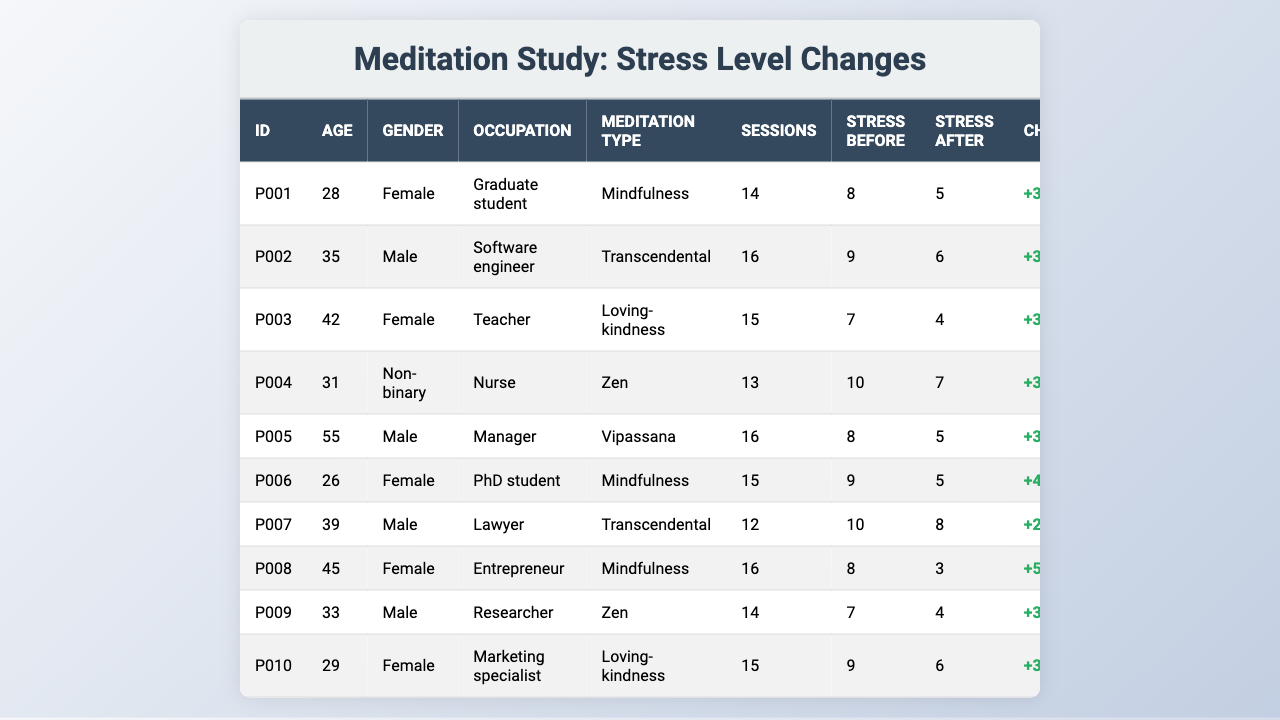What was the stress level of participant P003 before the meditation program? Looking at the table, participant P003 had a stress level of 7 before the meditation program, as indicated in the "Stress Before" column.
Answer: 7 What type of meditation did participant P008 practice? According to the table, participant P008 practiced Mindfulness meditation, which is listed under the "Meditation Type" column.
Answer: Mindfulness How many sessions did participant P005 attend? In the table, participant P005 attended a total of 16 sessions, as shown in the "Sessions" column.
Answer: 16 What is the stress change for participant P001? The stress change for participant P001 can be calculated by subtracting the stress level after meditation (5) from the stress level before meditation (8), resulting in a change of +3.
Answer: +3 What is the average stress level before the meditation program for all participants? To find the average stress level before meditation, add all the "Stress Before" values (8 + 9 + 7 + 10 + 8 + 9 + 10 + 8 + 7 + 9 = 87) and divide by the number of participants (10). This gives an average of 87/10 = 8.7.
Answer: 8.7 Did participant P007 experience a decrease in stress levels after the program? By comparing the stress levels, participant P007 had a stress level before meditation of 10 and after meditation of 8. Since 8 is less than 10, there is a decrease in stress levels.
Answer: Yes Who attended the most sessions, and how many sessions did they attend? Looking at the table, both participant P002 and P005 attended the most sessions, with each attending 16 sessions.
Answer: P002 and P005, 16 sessions Which meditation type resulted in the largest decrease in stress levels? Analyze the changes for each meditation type: Mindfulness (3, 2), Transcendental (3, 2), Loving-kindness (3, 3), Zen (3, 3), and Vipassana (3, 3). The largest decrease was observed with Loving-kindness, with a change of 3 (from 7 to 4).
Answer: Loving-kindness What percentage of participants reported lower stress levels after the program? There are 10 participants in total, and 6 of them reported lower stress levels (P001, P002, P003, P006, P008, P009). Calculating the percentage gives (6/10) * 100 = 60%.
Answer: 60% Is there any participant who reported the same stress level before and after the program? By examining the stress levels before and after for each participant, none reported the same stress level before and after the program, as all values differ.
Answer: No 